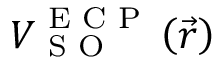Convert formula to latex. <formula><loc_0><loc_0><loc_500><loc_500>V _ { S O } ^ { E C P } \left ( \vec { r } \right )</formula> 